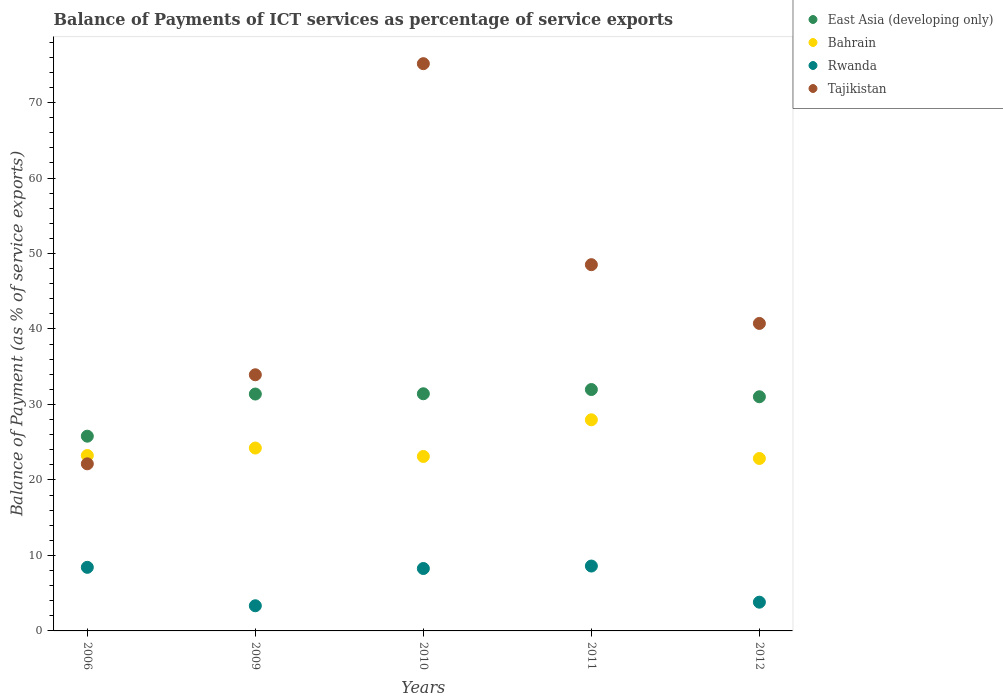Is the number of dotlines equal to the number of legend labels?
Provide a short and direct response. Yes. What is the balance of payments of ICT services in Rwanda in 2006?
Provide a succinct answer. 8.42. Across all years, what is the maximum balance of payments of ICT services in East Asia (developing only)?
Offer a very short reply. 31.98. Across all years, what is the minimum balance of payments of ICT services in Tajikistan?
Provide a succinct answer. 22.14. In which year was the balance of payments of ICT services in Bahrain minimum?
Offer a terse response. 2012. What is the total balance of payments of ICT services in East Asia (developing only) in the graph?
Ensure brevity in your answer.  151.6. What is the difference between the balance of payments of ICT services in Bahrain in 2009 and that in 2012?
Your response must be concise. 1.38. What is the difference between the balance of payments of ICT services in Tajikistan in 2006 and the balance of payments of ICT services in Rwanda in 2011?
Provide a succinct answer. 13.54. What is the average balance of payments of ICT services in Tajikistan per year?
Keep it short and to the point. 44.09. In the year 2006, what is the difference between the balance of payments of ICT services in Bahrain and balance of payments of ICT services in Tajikistan?
Offer a terse response. 1.1. What is the ratio of the balance of payments of ICT services in Rwanda in 2006 to that in 2010?
Provide a short and direct response. 1.02. Is the difference between the balance of payments of ICT services in Bahrain in 2010 and 2012 greater than the difference between the balance of payments of ICT services in Tajikistan in 2010 and 2012?
Provide a succinct answer. No. What is the difference between the highest and the second highest balance of payments of ICT services in Tajikistan?
Your answer should be compact. 26.63. What is the difference between the highest and the lowest balance of payments of ICT services in Tajikistan?
Give a very brief answer. 53.01. In how many years, is the balance of payments of ICT services in Rwanda greater than the average balance of payments of ICT services in Rwanda taken over all years?
Your answer should be compact. 3. Is the balance of payments of ICT services in East Asia (developing only) strictly greater than the balance of payments of ICT services in Rwanda over the years?
Make the answer very short. Yes. How many dotlines are there?
Your answer should be very brief. 4. How many years are there in the graph?
Ensure brevity in your answer.  5. Does the graph contain any zero values?
Provide a succinct answer. No. Does the graph contain grids?
Give a very brief answer. No. How many legend labels are there?
Offer a very short reply. 4. How are the legend labels stacked?
Your answer should be compact. Vertical. What is the title of the graph?
Offer a very short reply. Balance of Payments of ICT services as percentage of service exports. What is the label or title of the X-axis?
Provide a short and direct response. Years. What is the label or title of the Y-axis?
Your answer should be compact. Balance of Payment (as % of service exports). What is the Balance of Payment (as % of service exports) of East Asia (developing only) in 2006?
Offer a very short reply. 25.8. What is the Balance of Payment (as % of service exports) of Bahrain in 2006?
Ensure brevity in your answer.  23.24. What is the Balance of Payment (as % of service exports) in Rwanda in 2006?
Your answer should be compact. 8.42. What is the Balance of Payment (as % of service exports) in Tajikistan in 2006?
Ensure brevity in your answer.  22.14. What is the Balance of Payment (as % of service exports) in East Asia (developing only) in 2009?
Give a very brief answer. 31.38. What is the Balance of Payment (as % of service exports) in Bahrain in 2009?
Your answer should be compact. 24.23. What is the Balance of Payment (as % of service exports) in Rwanda in 2009?
Offer a very short reply. 3.33. What is the Balance of Payment (as % of service exports) in Tajikistan in 2009?
Offer a terse response. 33.93. What is the Balance of Payment (as % of service exports) in East Asia (developing only) in 2010?
Ensure brevity in your answer.  31.42. What is the Balance of Payment (as % of service exports) of Bahrain in 2010?
Ensure brevity in your answer.  23.11. What is the Balance of Payment (as % of service exports) in Rwanda in 2010?
Offer a terse response. 8.27. What is the Balance of Payment (as % of service exports) of Tajikistan in 2010?
Provide a short and direct response. 75.15. What is the Balance of Payment (as % of service exports) of East Asia (developing only) in 2011?
Make the answer very short. 31.98. What is the Balance of Payment (as % of service exports) of Bahrain in 2011?
Give a very brief answer. 27.97. What is the Balance of Payment (as % of service exports) of Rwanda in 2011?
Keep it short and to the point. 8.59. What is the Balance of Payment (as % of service exports) of Tajikistan in 2011?
Provide a succinct answer. 48.52. What is the Balance of Payment (as % of service exports) in East Asia (developing only) in 2012?
Offer a very short reply. 31.02. What is the Balance of Payment (as % of service exports) of Bahrain in 2012?
Offer a very short reply. 22.84. What is the Balance of Payment (as % of service exports) in Rwanda in 2012?
Provide a succinct answer. 3.81. What is the Balance of Payment (as % of service exports) in Tajikistan in 2012?
Provide a succinct answer. 40.74. Across all years, what is the maximum Balance of Payment (as % of service exports) of East Asia (developing only)?
Your response must be concise. 31.98. Across all years, what is the maximum Balance of Payment (as % of service exports) in Bahrain?
Give a very brief answer. 27.97. Across all years, what is the maximum Balance of Payment (as % of service exports) of Rwanda?
Provide a short and direct response. 8.59. Across all years, what is the maximum Balance of Payment (as % of service exports) in Tajikistan?
Give a very brief answer. 75.15. Across all years, what is the minimum Balance of Payment (as % of service exports) of East Asia (developing only)?
Your response must be concise. 25.8. Across all years, what is the minimum Balance of Payment (as % of service exports) in Bahrain?
Make the answer very short. 22.84. Across all years, what is the minimum Balance of Payment (as % of service exports) in Rwanda?
Give a very brief answer. 3.33. Across all years, what is the minimum Balance of Payment (as % of service exports) of Tajikistan?
Make the answer very short. 22.14. What is the total Balance of Payment (as % of service exports) of East Asia (developing only) in the graph?
Ensure brevity in your answer.  151.6. What is the total Balance of Payment (as % of service exports) of Bahrain in the graph?
Offer a very short reply. 121.39. What is the total Balance of Payment (as % of service exports) of Rwanda in the graph?
Provide a succinct answer. 32.43. What is the total Balance of Payment (as % of service exports) in Tajikistan in the graph?
Give a very brief answer. 220.47. What is the difference between the Balance of Payment (as % of service exports) of East Asia (developing only) in 2006 and that in 2009?
Provide a short and direct response. -5.58. What is the difference between the Balance of Payment (as % of service exports) in Bahrain in 2006 and that in 2009?
Your answer should be very brief. -0.99. What is the difference between the Balance of Payment (as % of service exports) of Rwanda in 2006 and that in 2009?
Your answer should be compact. 5.09. What is the difference between the Balance of Payment (as % of service exports) of Tajikistan in 2006 and that in 2009?
Keep it short and to the point. -11.8. What is the difference between the Balance of Payment (as % of service exports) of East Asia (developing only) in 2006 and that in 2010?
Your response must be concise. -5.62. What is the difference between the Balance of Payment (as % of service exports) of Bahrain in 2006 and that in 2010?
Your response must be concise. 0.12. What is the difference between the Balance of Payment (as % of service exports) of Rwanda in 2006 and that in 2010?
Your response must be concise. 0.16. What is the difference between the Balance of Payment (as % of service exports) of Tajikistan in 2006 and that in 2010?
Give a very brief answer. -53.01. What is the difference between the Balance of Payment (as % of service exports) of East Asia (developing only) in 2006 and that in 2011?
Your answer should be compact. -6.18. What is the difference between the Balance of Payment (as % of service exports) of Bahrain in 2006 and that in 2011?
Provide a short and direct response. -4.73. What is the difference between the Balance of Payment (as % of service exports) in Rwanda in 2006 and that in 2011?
Your answer should be very brief. -0.17. What is the difference between the Balance of Payment (as % of service exports) in Tajikistan in 2006 and that in 2011?
Your response must be concise. -26.38. What is the difference between the Balance of Payment (as % of service exports) of East Asia (developing only) in 2006 and that in 2012?
Offer a terse response. -5.22. What is the difference between the Balance of Payment (as % of service exports) in Bahrain in 2006 and that in 2012?
Offer a very short reply. 0.39. What is the difference between the Balance of Payment (as % of service exports) of Rwanda in 2006 and that in 2012?
Provide a short and direct response. 4.62. What is the difference between the Balance of Payment (as % of service exports) in Tajikistan in 2006 and that in 2012?
Your answer should be very brief. -18.6. What is the difference between the Balance of Payment (as % of service exports) of East Asia (developing only) in 2009 and that in 2010?
Offer a very short reply. -0.04. What is the difference between the Balance of Payment (as % of service exports) in Bahrain in 2009 and that in 2010?
Offer a terse response. 1.11. What is the difference between the Balance of Payment (as % of service exports) in Rwanda in 2009 and that in 2010?
Offer a terse response. -4.93. What is the difference between the Balance of Payment (as % of service exports) of Tajikistan in 2009 and that in 2010?
Provide a succinct answer. -41.21. What is the difference between the Balance of Payment (as % of service exports) in East Asia (developing only) in 2009 and that in 2011?
Provide a succinct answer. -0.6. What is the difference between the Balance of Payment (as % of service exports) of Bahrain in 2009 and that in 2011?
Make the answer very short. -3.74. What is the difference between the Balance of Payment (as % of service exports) in Rwanda in 2009 and that in 2011?
Offer a very short reply. -5.26. What is the difference between the Balance of Payment (as % of service exports) of Tajikistan in 2009 and that in 2011?
Your answer should be compact. -14.58. What is the difference between the Balance of Payment (as % of service exports) of East Asia (developing only) in 2009 and that in 2012?
Give a very brief answer. 0.36. What is the difference between the Balance of Payment (as % of service exports) in Bahrain in 2009 and that in 2012?
Your answer should be very brief. 1.38. What is the difference between the Balance of Payment (as % of service exports) in Rwanda in 2009 and that in 2012?
Offer a very short reply. -0.47. What is the difference between the Balance of Payment (as % of service exports) of Tajikistan in 2009 and that in 2012?
Provide a short and direct response. -6.8. What is the difference between the Balance of Payment (as % of service exports) in East Asia (developing only) in 2010 and that in 2011?
Keep it short and to the point. -0.56. What is the difference between the Balance of Payment (as % of service exports) in Bahrain in 2010 and that in 2011?
Make the answer very short. -4.86. What is the difference between the Balance of Payment (as % of service exports) in Rwanda in 2010 and that in 2011?
Offer a terse response. -0.33. What is the difference between the Balance of Payment (as % of service exports) of Tajikistan in 2010 and that in 2011?
Your answer should be very brief. 26.63. What is the difference between the Balance of Payment (as % of service exports) in East Asia (developing only) in 2010 and that in 2012?
Make the answer very short. 0.4. What is the difference between the Balance of Payment (as % of service exports) in Bahrain in 2010 and that in 2012?
Keep it short and to the point. 0.27. What is the difference between the Balance of Payment (as % of service exports) of Rwanda in 2010 and that in 2012?
Your response must be concise. 4.46. What is the difference between the Balance of Payment (as % of service exports) of Tajikistan in 2010 and that in 2012?
Offer a terse response. 34.41. What is the difference between the Balance of Payment (as % of service exports) of East Asia (developing only) in 2011 and that in 2012?
Give a very brief answer. 0.96. What is the difference between the Balance of Payment (as % of service exports) in Bahrain in 2011 and that in 2012?
Provide a succinct answer. 5.12. What is the difference between the Balance of Payment (as % of service exports) in Rwanda in 2011 and that in 2012?
Offer a terse response. 4.79. What is the difference between the Balance of Payment (as % of service exports) in Tajikistan in 2011 and that in 2012?
Ensure brevity in your answer.  7.78. What is the difference between the Balance of Payment (as % of service exports) in East Asia (developing only) in 2006 and the Balance of Payment (as % of service exports) in Bahrain in 2009?
Give a very brief answer. 1.57. What is the difference between the Balance of Payment (as % of service exports) of East Asia (developing only) in 2006 and the Balance of Payment (as % of service exports) of Rwanda in 2009?
Your answer should be very brief. 22.46. What is the difference between the Balance of Payment (as % of service exports) in East Asia (developing only) in 2006 and the Balance of Payment (as % of service exports) in Tajikistan in 2009?
Offer a terse response. -8.14. What is the difference between the Balance of Payment (as % of service exports) in Bahrain in 2006 and the Balance of Payment (as % of service exports) in Rwanda in 2009?
Offer a terse response. 19.9. What is the difference between the Balance of Payment (as % of service exports) of Bahrain in 2006 and the Balance of Payment (as % of service exports) of Tajikistan in 2009?
Provide a succinct answer. -10.7. What is the difference between the Balance of Payment (as % of service exports) in Rwanda in 2006 and the Balance of Payment (as % of service exports) in Tajikistan in 2009?
Your answer should be very brief. -25.51. What is the difference between the Balance of Payment (as % of service exports) in East Asia (developing only) in 2006 and the Balance of Payment (as % of service exports) in Bahrain in 2010?
Your answer should be very brief. 2.68. What is the difference between the Balance of Payment (as % of service exports) of East Asia (developing only) in 2006 and the Balance of Payment (as % of service exports) of Rwanda in 2010?
Give a very brief answer. 17.53. What is the difference between the Balance of Payment (as % of service exports) in East Asia (developing only) in 2006 and the Balance of Payment (as % of service exports) in Tajikistan in 2010?
Provide a short and direct response. -49.35. What is the difference between the Balance of Payment (as % of service exports) in Bahrain in 2006 and the Balance of Payment (as % of service exports) in Rwanda in 2010?
Keep it short and to the point. 14.97. What is the difference between the Balance of Payment (as % of service exports) in Bahrain in 2006 and the Balance of Payment (as % of service exports) in Tajikistan in 2010?
Ensure brevity in your answer.  -51.91. What is the difference between the Balance of Payment (as % of service exports) of Rwanda in 2006 and the Balance of Payment (as % of service exports) of Tajikistan in 2010?
Provide a short and direct response. -66.72. What is the difference between the Balance of Payment (as % of service exports) in East Asia (developing only) in 2006 and the Balance of Payment (as % of service exports) in Bahrain in 2011?
Provide a short and direct response. -2.17. What is the difference between the Balance of Payment (as % of service exports) of East Asia (developing only) in 2006 and the Balance of Payment (as % of service exports) of Rwanda in 2011?
Make the answer very short. 17.2. What is the difference between the Balance of Payment (as % of service exports) of East Asia (developing only) in 2006 and the Balance of Payment (as % of service exports) of Tajikistan in 2011?
Your answer should be very brief. -22.72. What is the difference between the Balance of Payment (as % of service exports) of Bahrain in 2006 and the Balance of Payment (as % of service exports) of Rwanda in 2011?
Offer a very short reply. 14.64. What is the difference between the Balance of Payment (as % of service exports) in Bahrain in 2006 and the Balance of Payment (as % of service exports) in Tajikistan in 2011?
Your answer should be very brief. -25.28. What is the difference between the Balance of Payment (as % of service exports) of Rwanda in 2006 and the Balance of Payment (as % of service exports) of Tajikistan in 2011?
Keep it short and to the point. -40.09. What is the difference between the Balance of Payment (as % of service exports) in East Asia (developing only) in 2006 and the Balance of Payment (as % of service exports) in Bahrain in 2012?
Your answer should be very brief. 2.95. What is the difference between the Balance of Payment (as % of service exports) in East Asia (developing only) in 2006 and the Balance of Payment (as % of service exports) in Rwanda in 2012?
Give a very brief answer. 21.99. What is the difference between the Balance of Payment (as % of service exports) of East Asia (developing only) in 2006 and the Balance of Payment (as % of service exports) of Tajikistan in 2012?
Your response must be concise. -14.94. What is the difference between the Balance of Payment (as % of service exports) of Bahrain in 2006 and the Balance of Payment (as % of service exports) of Rwanda in 2012?
Offer a very short reply. 19.43. What is the difference between the Balance of Payment (as % of service exports) in Bahrain in 2006 and the Balance of Payment (as % of service exports) in Tajikistan in 2012?
Provide a short and direct response. -17.5. What is the difference between the Balance of Payment (as % of service exports) in Rwanda in 2006 and the Balance of Payment (as % of service exports) in Tajikistan in 2012?
Your answer should be compact. -32.31. What is the difference between the Balance of Payment (as % of service exports) of East Asia (developing only) in 2009 and the Balance of Payment (as % of service exports) of Bahrain in 2010?
Your response must be concise. 8.27. What is the difference between the Balance of Payment (as % of service exports) in East Asia (developing only) in 2009 and the Balance of Payment (as % of service exports) in Rwanda in 2010?
Make the answer very short. 23.11. What is the difference between the Balance of Payment (as % of service exports) of East Asia (developing only) in 2009 and the Balance of Payment (as % of service exports) of Tajikistan in 2010?
Your answer should be very brief. -43.77. What is the difference between the Balance of Payment (as % of service exports) in Bahrain in 2009 and the Balance of Payment (as % of service exports) in Rwanda in 2010?
Your answer should be very brief. 15.96. What is the difference between the Balance of Payment (as % of service exports) in Bahrain in 2009 and the Balance of Payment (as % of service exports) in Tajikistan in 2010?
Offer a terse response. -50.92. What is the difference between the Balance of Payment (as % of service exports) of Rwanda in 2009 and the Balance of Payment (as % of service exports) of Tajikistan in 2010?
Your answer should be compact. -71.81. What is the difference between the Balance of Payment (as % of service exports) in East Asia (developing only) in 2009 and the Balance of Payment (as % of service exports) in Bahrain in 2011?
Provide a short and direct response. 3.41. What is the difference between the Balance of Payment (as % of service exports) in East Asia (developing only) in 2009 and the Balance of Payment (as % of service exports) in Rwanda in 2011?
Offer a very short reply. 22.79. What is the difference between the Balance of Payment (as % of service exports) of East Asia (developing only) in 2009 and the Balance of Payment (as % of service exports) of Tajikistan in 2011?
Ensure brevity in your answer.  -17.14. What is the difference between the Balance of Payment (as % of service exports) in Bahrain in 2009 and the Balance of Payment (as % of service exports) in Rwanda in 2011?
Provide a short and direct response. 15.63. What is the difference between the Balance of Payment (as % of service exports) in Bahrain in 2009 and the Balance of Payment (as % of service exports) in Tajikistan in 2011?
Your answer should be compact. -24.29. What is the difference between the Balance of Payment (as % of service exports) in Rwanda in 2009 and the Balance of Payment (as % of service exports) in Tajikistan in 2011?
Offer a terse response. -45.18. What is the difference between the Balance of Payment (as % of service exports) of East Asia (developing only) in 2009 and the Balance of Payment (as % of service exports) of Bahrain in 2012?
Your answer should be compact. 8.54. What is the difference between the Balance of Payment (as % of service exports) of East Asia (developing only) in 2009 and the Balance of Payment (as % of service exports) of Rwanda in 2012?
Offer a very short reply. 27.57. What is the difference between the Balance of Payment (as % of service exports) of East Asia (developing only) in 2009 and the Balance of Payment (as % of service exports) of Tajikistan in 2012?
Your answer should be compact. -9.35. What is the difference between the Balance of Payment (as % of service exports) of Bahrain in 2009 and the Balance of Payment (as % of service exports) of Rwanda in 2012?
Keep it short and to the point. 20.42. What is the difference between the Balance of Payment (as % of service exports) in Bahrain in 2009 and the Balance of Payment (as % of service exports) in Tajikistan in 2012?
Keep it short and to the point. -16.51. What is the difference between the Balance of Payment (as % of service exports) in Rwanda in 2009 and the Balance of Payment (as % of service exports) in Tajikistan in 2012?
Your answer should be compact. -37.4. What is the difference between the Balance of Payment (as % of service exports) of East Asia (developing only) in 2010 and the Balance of Payment (as % of service exports) of Bahrain in 2011?
Ensure brevity in your answer.  3.45. What is the difference between the Balance of Payment (as % of service exports) of East Asia (developing only) in 2010 and the Balance of Payment (as % of service exports) of Rwanda in 2011?
Offer a terse response. 22.82. What is the difference between the Balance of Payment (as % of service exports) in East Asia (developing only) in 2010 and the Balance of Payment (as % of service exports) in Tajikistan in 2011?
Offer a very short reply. -17.1. What is the difference between the Balance of Payment (as % of service exports) in Bahrain in 2010 and the Balance of Payment (as % of service exports) in Rwanda in 2011?
Give a very brief answer. 14.52. What is the difference between the Balance of Payment (as % of service exports) of Bahrain in 2010 and the Balance of Payment (as % of service exports) of Tajikistan in 2011?
Provide a short and direct response. -25.41. What is the difference between the Balance of Payment (as % of service exports) of Rwanda in 2010 and the Balance of Payment (as % of service exports) of Tajikistan in 2011?
Ensure brevity in your answer.  -40.25. What is the difference between the Balance of Payment (as % of service exports) in East Asia (developing only) in 2010 and the Balance of Payment (as % of service exports) in Bahrain in 2012?
Provide a short and direct response. 8.57. What is the difference between the Balance of Payment (as % of service exports) of East Asia (developing only) in 2010 and the Balance of Payment (as % of service exports) of Rwanda in 2012?
Ensure brevity in your answer.  27.61. What is the difference between the Balance of Payment (as % of service exports) in East Asia (developing only) in 2010 and the Balance of Payment (as % of service exports) in Tajikistan in 2012?
Offer a terse response. -9.32. What is the difference between the Balance of Payment (as % of service exports) of Bahrain in 2010 and the Balance of Payment (as % of service exports) of Rwanda in 2012?
Offer a very short reply. 19.31. What is the difference between the Balance of Payment (as % of service exports) in Bahrain in 2010 and the Balance of Payment (as % of service exports) in Tajikistan in 2012?
Your response must be concise. -17.62. What is the difference between the Balance of Payment (as % of service exports) of Rwanda in 2010 and the Balance of Payment (as % of service exports) of Tajikistan in 2012?
Your answer should be compact. -32.47. What is the difference between the Balance of Payment (as % of service exports) of East Asia (developing only) in 2011 and the Balance of Payment (as % of service exports) of Bahrain in 2012?
Ensure brevity in your answer.  9.13. What is the difference between the Balance of Payment (as % of service exports) of East Asia (developing only) in 2011 and the Balance of Payment (as % of service exports) of Rwanda in 2012?
Ensure brevity in your answer.  28.17. What is the difference between the Balance of Payment (as % of service exports) in East Asia (developing only) in 2011 and the Balance of Payment (as % of service exports) in Tajikistan in 2012?
Your answer should be very brief. -8.76. What is the difference between the Balance of Payment (as % of service exports) in Bahrain in 2011 and the Balance of Payment (as % of service exports) in Rwanda in 2012?
Keep it short and to the point. 24.16. What is the difference between the Balance of Payment (as % of service exports) in Bahrain in 2011 and the Balance of Payment (as % of service exports) in Tajikistan in 2012?
Make the answer very short. -12.77. What is the difference between the Balance of Payment (as % of service exports) of Rwanda in 2011 and the Balance of Payment (as % of service exports) of Tajikistan in 2012?
Ensure brevity in your answer.  -32.14. What is the average Balance of Payment (as % of service exports) of East Asia (developing only) per year?
Your response must be concise. 30.32. What is the average Balance of Payment (as % of service exports) of Bahrain per year?
Offer a very short reply. 24.28. What is the average Balance of Payment (as % of service exports) in Rwanda per year?
Your answer should be very brief. 6.49. What is the average Balance of Payment (as % of service exports) in Tajikistan per year?
Provide a succinct answer. 44.09. In the year 2006, what is the difference between the Balance of Payment (as % of service exports) of East Asia (developing only) and Balance of Payment (as % of service exports) of Bahrain?
Make the answer very short. 2.56. In the year 2006, what is the difference between the Balance of Payment (as % of service exports) in East Asia (developing only) and Balance of Payment (as % of service exports) in Rwanda?
Give a very brief answer. 17.37. In the year 2006, what is the difference between the Balance of Payment (as % of service exports) in East Asia (developing only) and Balance of Payment (as % of service exports) in Tajikistan?
Offer a terse response. 3.66. In the year 2006, what is the difference between the Balance of Payment (as % of service exports) of Bahrain and Balance of Payment (as % of service exports) of Rwanda?
Offer a very short reply. 14.81. In the year 2006, what is the difference between the Balance of Payment (as % of service exports) of Bahrain and Balance of Payment (as % of service exports) of Tajikistan?
Your answer should be compact. 1.1. In the year 2006, what is the difference between the Balance of Payment (as % of service exports) in Rwanda and Balance of Payment (as % of service exports) in Tajikistan?
Make the answer very short. -13.71. In the year 2009, what is the difference between the Balance of Payment (as % of service exports) of East Asia (developing only) and Balance of Payment (as % of service exports) of Bahrain?
Give a very brief answer. 7.15. In the year 2009, what is the difference between the Balance of Payment (as % of service exports) in East Asia (developing only) and Balance of Payment (as % of service exports) in Rwanda?
Provide a short and direct response. 28.05. In the year 2009, what is the difference between the Balance of Payment (as % of service exports) in East Asia (developing only) and Balance of Payment (as % of service exports) in Tajikistan?
Ensure brevity in your answer.  -2.55. In the year 2009, what is the difference between the Balance of Payment (as % of service exports) of Bahrain and Balance of Payment (as % of service exports) of Rwanda?
Ensure brevity in your answer.  20.89. In the year 2009, what is the difference between the Balance of Payment (as % of service exports) in Bahrain and Balance of Payment (as % of service exports) in Tajikistan?
Offer a terse response. -9.71. In the year 2009, what is the difference between the Balance of Payment (as % of service exports) in Rwanda and Balance of Payment (as % of service exports) in Tajikistan?
Offer a terse response. -30.6. In the year 2010, what is the difference between the Balance of Payment (as % of service exports) in East Asia (developing only) and Balance of Payment (as % of service exports) in Bahrain?
Make the answer very short. 8.3. In the year 2010, what is the difference between the Balance of Payment (as % of service exports) in East Asia (developing only) and Balance of Payment (as % of service exports) in Rwanda?
Keep it short and to the point. 23.15. In the year 2010, what is the difference between the Balance of Payment (as % of service exports) of East Asia (developing only) and Balance of Payment (as % of service exports) of Tajikistan?
Give a very brief answer. -43.73. In the year 2010, what is the difference between the Balance of Payment (as % of service exports) in Bahrain and Balance of Payment (as % of service exports) in Rwanda?
Provide a succinct answer. 14.85. In the year 2010, what is the difference between the Balance of Payment (as % of service exports) in Bahrain and Balance of Payment (as % of service exports) in Tajikistan?
Offer a very short reply. -52.03. In the year 2010, what is the difference between the Balance of Payment (as % of service exports) in Rwanda and Balance of Payment (as % of service exports) in Tajikistan?
Provide a short and direct response. -66.88. In the year 2011, what is the difference between the Balance of Payment (as % of service exports) in East Asia (developing only) and Balance of Payment (as % of service exports) in Bahrain?
Ensure brevity in your answer.  4.01. In the year 2011, what is the difference between the Balance of Payment (as % of service exports) of East Asia (developing only) and Balance of Payment (as % of service exports) of Rwanda?
Keep it short and to the point. 23.38. In the year 2011, what is the difference between the Balance of Payment (as % of service exports) in East Asia (developing only) and Balance of Payment (as % of service exports) in Tajikistan?
Keep it short and to the point. -16.54. In the year 2011, what is the difference between the Balance of Payment (as % of service exports) in Bahrain and Balance of Payment (as % of service exports) in Rwanda?
Make the answer very short. 19.38. In the year 2011, what is the difference between the Balance of Payment (as % of service exports) of Bahrain and Balance of Payment (as % of service exports) of Tajikistan?
Offer a terse response. -20.55. In the year 2011, what is the difference between the Balance of Payment (as % of service exports) in Rwanda and Balance of Payment (as % of service exports) in Tajikistan?
Give a very brief answer. -39.92. In the year 2012, what is the difference between the Balance of Payment (as % of service exports) in East Asia (developing only) and Balance of Payment (as % of service exports) in Bahrain?
Your response must be concise. 8.18. In the year 2012, what is the difference between the Balance of Payment (as % of service exports) in East Asia (developing only) and Balance of Payment (as % of service exports) in Rwanda?
Make the answer very short. 27.21. In the year 2012, what is the difference between the Balance of Payment (as % of service exports) of East Asia (developing only) and Balance of Payment (as % of service exports) of Tajikistan?
Make the answer very short. -9.71. In the year 2012, what is the difference between the Balance of Payment (as % of service exports) in Bahrain and Balance of Payment (as % of service exports) in Rwanda?
Your response must be concise. 19.04. In the year 2012, what is the difference between the Balance of Payment (as % of service exports) of Bahrain and Balance of Payment (as % of service exports) of Tajikistan?
Provide a succinct answer. -17.89. In the year 2012, what is the difference between the Balance of Payment (as % of service exports) in Rwanda and Balance of Payment (as % of service exports) in Tajikistan?
Provide a short and direct response. -36.93. What is the ratio of the Balance of Payment (as % of service exports) of East Asia (developing only) in 2006 to that in 2009?
Provide a succinct answer. 0.82. What is the ratio of the Balance of Payment (as % of service exports) in Bahrain in 2006 to that in 2009?
Keep it short and to the point. 0.96. What is the ratio of the Balance of Payment (as % of service exports) of Rwanda in 2006 to that in 2009?
Provide a succinct answer. 2.53. What is the ratio of the Balance of Payment (as % of service exports) of Tajikistan in 2006 to that in 2009?
Your response must be concise. 0.65. What is the ratio of the Balance of Payment (as % of service exports) of East Asia (developing only) in 2006 to that in 2010?
Provide a succinct answer. 0.82. What is the ratio of the Balance of Payment (as % of service exports) in Rwanda in 2006 to that in 2010?
Keep it short and to the point. 1.02. What is the ratio of the Balance of Payment (as % of service exports) in Tajikistan in 2006 to that in 2010?
Give a very brief answer. 0.29. What is the ratio of the Balance of Payment (as % of service exports) in East Asia (developing only) in 2006 to that in 2011?
Ensure brevity in your answer.  0.81. What is the ratio of the Balance of Payment (as % of service exports) of Bahrain in 2006 to that in 2011?
Provide a succinct answer. 0.83. What is the ratio of the Balance of Payment (as % of service exports) in Rwanda in 2006 to that in 2011?
Keep it short and to the point. 0.98. What is the ratio of the Balance of Payment (as % of service exports) in Tajikistan in 2006 to that in 2011?
Your response must be concise. 0.46. What is the ratio of the Balance of Payment (as % of service exports) in East Asia (developing only) in 2006 to that in 2012?
Make the answer very short. 0.83. What is the ratio of the Balance of Payment (as % of service exports) of Bahrain in 2006 to that in 2012?
Ensure brevity in your answer.  1.02. What is the ratio of the Balance of Payment (as % of service exports) of Rwanda in 2006 to that in 2012?
Provide a short and direct response. 2.21. What is the ratio of the Balance of Payment (as % of service exports) in Tajikistan in 2006 to that in 2012?
Provide a succinct answer. 0.54. What is the ratio of the Balance of Payment (as % of service exports) in East Asia (developing only) in 2009 to that in 2010?
Offer a very short reply. 1. What is the ratio of the Balance of Payment (as % of service exports) of Bahrain in 2009 to that in 2010?
Your response must be concise. 1.05. What is the ratio of the Balance of Payment (as % of service exports) of Rwanda in 2009 to that in 2010?
Offer a very short reply. 0.4. What is the ratio of the Balance of Payment (as % of service exports) in Tajikistan in 2009 to that in 2010?
Keep it short and to the point. 0.45. What is the ratio of the Balance of Payment (as % of service exports) of East Asia (developing only) in 2009 to that in 2011?
Keep it short and to the point. 0.98. What is the ratio of the Balance of Payment (as % of service exports) of Bahrain in 2009 to that in 2011?
Offer a very short reply. 0.87. What is the ratio of the Balance of Payment (as % of service exports) of Rwanda in 2009 to that in 2011?
Provide a succinct answer. 0.39. What is the ratio of the Balance of Payment (as % of service exports) of Tajikistan in 2009 to that in 2011?
Provide a short and direct response. 0.7. What is the ratio of the Balance of Payment (as % of service exports) in East Asia (developing only) in 2009 to that in 2012?
Your answer should be compact. 1.01. What is the ratio of the Balance of Payment (as % of service exports) in Bahrain in 2009 to that in 2012?
Ensure brevity in your answer.  1.06. What is the ratio of the Balance of Payment (as % of service exports) of Rwanda in 2009 to that in 2012?
Offer a very short reply. 0.88. What is the ratio of the Balance of Payment (as % of service exports) in Tajikistan in 2009 to that in 2012?
Offer a very short reply. 0.83. What is the ratio of the Balance of Payment (as % of service exports) of East Asia (developing only) in 2010 to that in 2011?
Keep it short and to the point. 0.98. What is the ratio of the Balance of Payment (as % of service exports) in Bahrain in 2010 to that in 2011?
Your response must be concise. 0.83. What is the ratio of the Balance of Payment (as % of service exports) in Rwanda in 2010 to that in 2011?
Give a very brief answer. 0.96. What is the ratio of the Balance of Payment (as % of service exports) of Tajikistan in 2010 to that in 2011?
Your response must be concise. 1.55. What is the ratio of the Balance of Payment (as % of service exports) of East Asia (developing only) in 2010 to that in 2012?
Provide a short and direct response. 1.01. What is the ratio of the Balance of Payment (as % of service exports) in Bahrain in 2010 to that in 2012?
Ensure brevity in your answer.  1.01. What is the ratio of the Balance of Payment (as % of service exports) in Rwanda in 2010 to that in 2012?
Give a very brief answer. 2.17. What is the ratio of the Balance of Payment (as % of service exports) of Tajikistan in 2010 to that in 2012?
Give a very brief answer. 1.84. What is the ratio of the Balance of Payment (as % of service exports) of East Asia (developing only) in 2011 to that in 2012?
Provide a succinct answer. 1.03. What is the ratio of the Balance of Payment (as % of service exports) of Bahrain in 2011 to that in 2012?
Your answer should be very brief. 1.22. What is the ratio of the Balance of Payment (as % of service exports) in Rwanda in 2011 to that in 2012?
Provide a short and direct response. 2.26. What is the ratio of the Balance of Payment (as % of service exports) of Tajikistan in 2011 to that in 2012?
Ensure brevity in your answer.  1.19. What is the difference between the highest and the second highest Balance of Payment (as % of service exports) of East Asia (developing only)?
Your answer should be compact. 0.56. What is the difference between the highest and the second highest Balance of Payment (as % of service exports) in Bahrain?
Provide a succinct answer. 3.74. What is the difference between the highest and the second highest Balance of Payment (as % of service exports) in Rwanda?
Your response must be concise. 0.17. What is the difference between the highest and the second highest Balance of Payment (as % of service exports) in Tajikistan?
Ensure brevity in your answer.  26.63. What is the difference between the highest and the lowest Balance of Payment (as % of service exports) of East Asia (developing only)?
Offer a very short reply. 6.18. What is the difference between the highest and the lowest Balance of Payment (as % of service exports) of Bahrain?
Give a very brief answer. 5.12. What is the difference between the highest and the lowest Balance of Payment (as % of service exports) of Rwanda?
Your answer should be compact. 5.26. What is the difference between the highest and the lowest Balance of Payment (as % of service exports) of Tajikistan?
Provide a short and direct response. 53.01. 